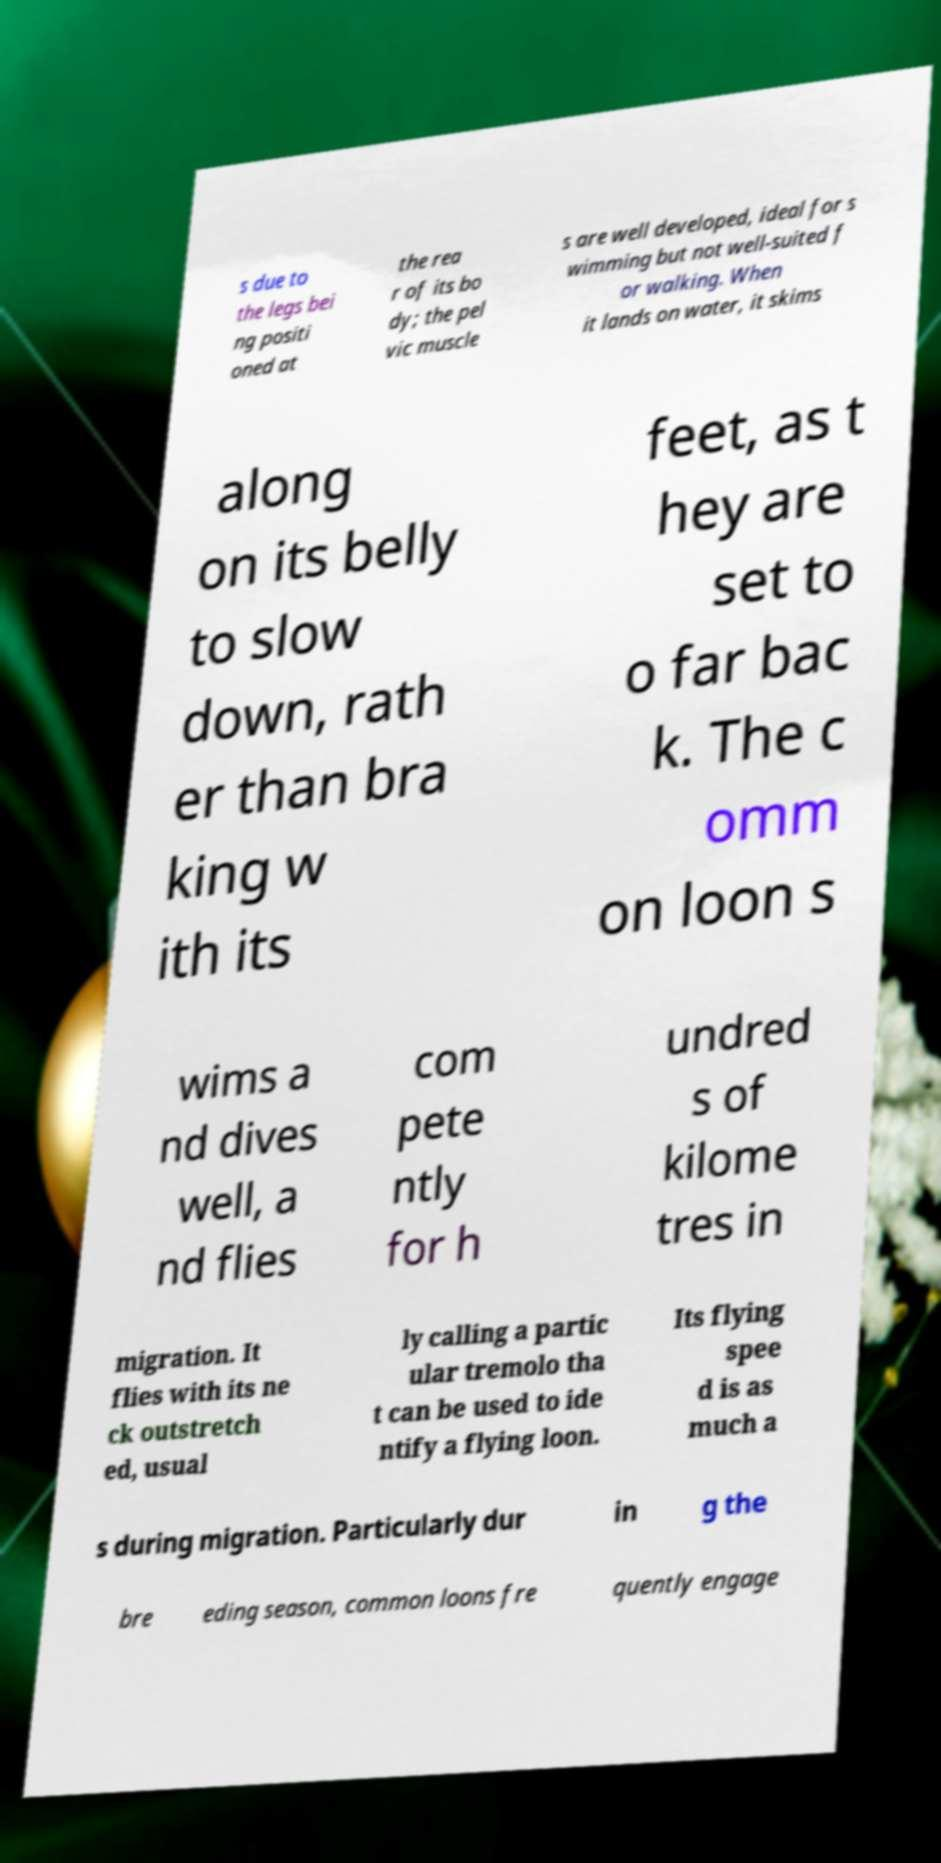Please identify and transcribe the text found in this image. s due to the legs bei ng positi oned at the rea r of its bo dy; the pel vic muscle s are well developed, ideal for s wimming but not well-suited f or walking. When it lands on water, it skims along on its belly to slow down, rath er than bra king w ith its feet, as t hey are set to o far bac k. The c omm on loon s wims a nd dives well, a nd flies com pete ntly for h undred s of kilome tres in migration. It flies with its ne ck outstretch ed, usual ly calling a partic ular tremolo tha t can be used to ide ntify a flying loon. Its flying spee d is as much a s during migration. Particularly dur in g the bre eding season, common loons fre quently engage 